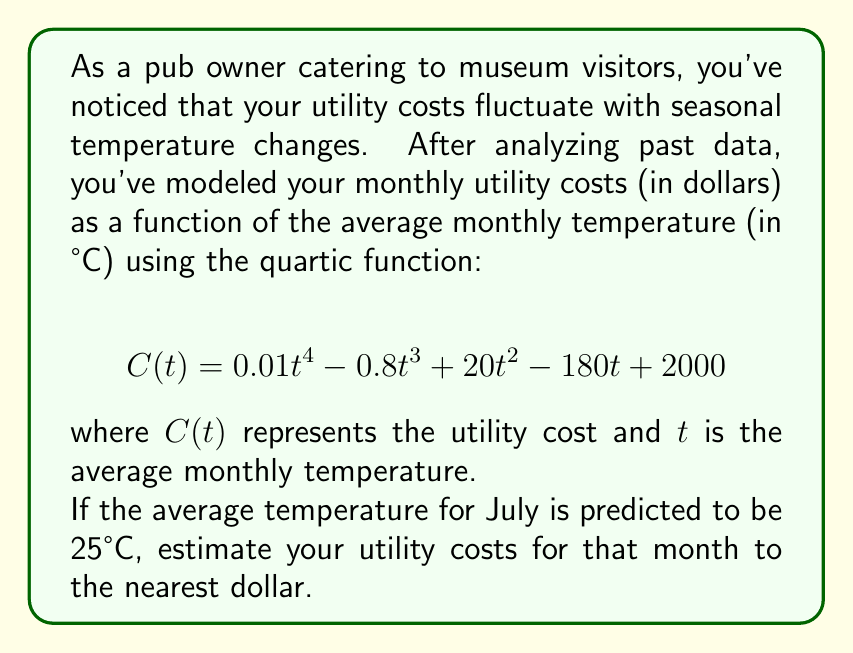Can you answer this question? To solve this problem, we need to evaluate the given function $C(t)$ at $t = 25$. Let's break it down step-by-step:

1) Our function is:
   $$ C(t) = 0.01t^4 - 0.8t^3 + 20t^2 - 180t + 2000 $$

2) We need to calculate $C(25)$. Let's substitute $t = 25$ into each term:

   a) $0.01t^4 = 0.01(25^4) = 0.01(390625) = 3906.25$
   
   b) $-0.8t^3 = -0.8(25^3) = -0.8(15625) = -12500$
   
   c) $20t^2 = 20(25^2) = 20(625) = 12500$
   
   d) $-180t = -180(25) = -4500$
   
   e) The constant term is 2000

3) Now, let's sum all these terms:

   $$ C(25) = 3906.25 - 12500 + 12500 - 4500 + 2000 $$

4) Simplifying:
   $$ C(25) = 1406.25 $$

5) Rounding to the nearest dollar:
   $$ C(25) \approx 1406 $$

Therefore, the estimated utility cost for July, when the average temperature is predicted to be 25°C, is $1406.
Answer: $1406 